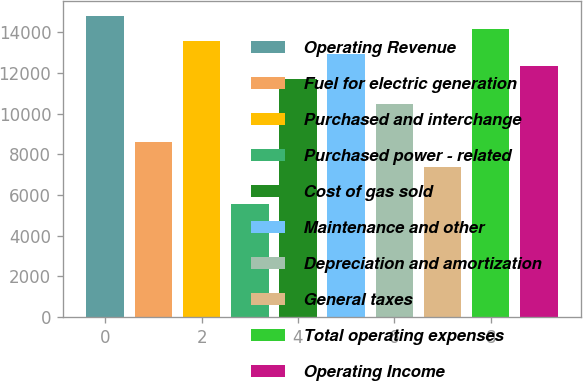<chart> <loc_0><loc_0><loc_500><loc_500><bar_chart><fcel>Operating Revenue<fcel>Fuel for electric generation<fcel>Purchased and interchange<fcel>Purchased power - related<fcel>Cost of gas sold<fcel>Maintenance and other<fcel>Depreciation and amortization<fcel>General taxes<fcel>Total operating expenses<fcel>Operating Income<nl><fcel>14794.6<fcel>8630.6<fcel>13561.8<fcel>5548.6<fcel>11712.6<fcel>12945.4<fcel>10479.8<fcel>7397.8<fcel>14178.2<fcel>12329<nl></chart> 